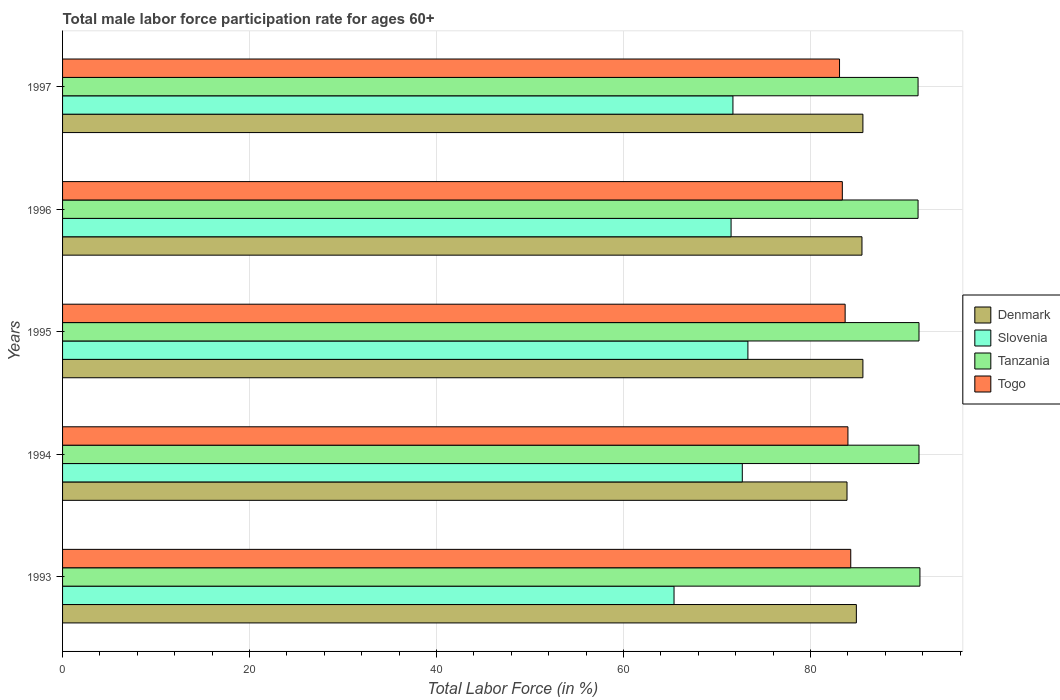How many different coloured bars are there?
Your answer should be very brief. 4. How many groups of bars are there?
Ensure brevity in your answer.  5. Are the number of bars per tick equal to the number of legend labels?
Ensure brevity in your answer.  Yes. Are the number of bars on each tick of the Y-axis equal?
Keep it short and to the point. Yes. How many bars are there on the 2nd tick from the top?
Keep it short and to the point. 4. How many bars are there on the 5th tick from the bottom?
Provide a short and direct response. 4. In how many cases, is the number of bars for a given year not equal to the number of legend labels?
Your answer should be compact. 0. What is the male labor force participation rate in Tanzania in 1995?
Your answer should be very brief. 91.6. Across all years, what is the maximum male labor force participation rate in Togo?
Offer a terse response. 84.3. Across all years, what is the minimum male labor force participation rate in Denmark?
Your answer should be very brief. 83.9. What is the total male labor force participation rate in Slovenia in the graph?
Provide a succinct answer. 354.6. What is the difference between the male labor force participation rate in Slovenia in 1993 and that in 1996?
Provide a short and direct response. -6.1. What is the difference between the male labor force participation rate in Tanzania in 1993 and the male labor force participation rate in Slovenia in 1996?
Make the answer very short. 20.2. What is the average male labor force participation rate in Togo per year?
Ensure brevity in your answer.  83.7. In how many years, is the male labor force participation rate in Denmark greater than 36 %?
Provide a succinct answer. 5. What is the ratio of the male labor force participation rate in Slovenia in 1993 to that in 1996?
Your response must be concise. 0.91. Is the male labor force participation rate in Denmark in 1994 less than that in 1995?
Your response must be concise. Yes. Is the difference between the male labor force participation rate in Denmark in 1994 and 1995 greater than the difference between the male labor force participation rate in Tanzania in 1994 and 1995?
Keep it short and to the point. No. What is the difference between the highest and the second highest male labor force participation rate in Tanzania?
Offer a terse response. 0.1. What is the difference between the highest and the lowest male labor force participation rate in Slovenia?
Make the answer very short. 7.9. In how many years, is the male labor force participation rate in Togo greater than the average male labor force participation rate in Togo taken over all years?
Give a very brief answer. 2. Is the sum of the male labor force participation rate in Denmark in 1995 and 1996 greater than the maximum male labor force participation rate in Slovenia across all years?
Your answer should be compact. Yes. What does the 3rd bar from the top in 1993 represents?
Make the answer very short. Slovenia. What does the 1st bar from the bottom in 1996 represents?
Give a very brief answer. Denmark. How many bars are there?
Ensure brevity in your answer.  20. Are all the bars in the graph horizontal?
Provide a succinct answer. Yes. How many years are there in the graph?
Provide a short and direct response. 5. Does the graph contain any zero values?
Your answer should be compact. No. What is the title of the graph?
Your answer should be very brief. Total male labor force participation rate for ages 60+. What is the label or title of the X-axis?
Provide a succinct answer. Total Labor Force (in %). What is the label or title of the Y-axis?
Your answer should be compact. Years. What is the Total Labor Force (in %) in Denmark in 1993?
Ensure brevity in your answer.  84.9. What is the Total Labor Force (in %) in Slovenia in 1993?
Keep it short and to the point. 65.4. What is the Total Labor Force (in %) in Tanzania in 1993?
Your answer should be very brief. 91.7. What is the Total Labor Force (in %) in Togo in 1993?
Your response must be concise. 84.3. What is the Total Labor Force (in %) of Denmark in 1994?
Your response must be concise. 83.9. What is the Total Labor Force (in %) of Slovenia in 1994?
Provide a succinct answer. 72.7. What is the Total Labor Force (in %) of Tanzania in 1994?
Your response must be concise. 91.6. What is the Total Labor Force (in %) of Denmark in 1995?
Your answer should be compact. 85.6. What is the Total Labor Force (in %) in Slovenia in 1995?
Offer a terse response. 73.3. What is the Total Labor Force (in %) in Tanzania in 1995?
Make the answer very short. 91.6. What is the Total Labor Force (in %) in Togo in 1995?
Make the answer very short. 83.7. What is the Total Labor Force (in %) in Denmark in 1996?
Provide a short and direct response. 85.5. What is the Total Labor Force (in %) in Slovenia in 1996?
Offer a very short reply. 71.5. What is the Total Labor Force (in %) in Tanzania in 1996?
Make the answer very short. 91.5. What is the Total Labor Force (in %) in Togo in 1996?
Offer a very short reply. 83.4. What is the Total Labor Force (in %) of Denmark in 1997?
Give a very brief answer. 85.6. What is the Total Labor Force (in %) in Slovenia in 1997?
Provide a succinct answer. 71.7. What is the Total Labor Force (in %) in Tanzania in 1997?
Your answer should be compact. 91.5. What is the Total Labor Force (in %) in Togo in 1997?
Offer a very short reply. 83.1. Across all years, what is the maximum Total Labor Force (in %) in Denmark?
Make the answer very short. 85.6. Across all years, what is the maximum Total Labor Force (in %) in Slovenia?
Keep it short and to the point. 73.3. Across all years, what is the maximum Total Labor Force (in %) of Tanzania?
Offer a very short reply. 91.7. Across all years, what is the maximum Total Labor Force (in %) of Togo?
Keep it short and to the point. 84.3. Across all years, what is the minimum Total Labor Force (in %) in Denmark?
Provide a short and direct response. 83.9. Across all years, what is the minimum Total Labor Force (in %) in Slovenia?
Offer a terse response. 65.4. Across all years, what is the minimum Total Labor Force (in %) in Tanzania?
Your answer should be compact. 91.5. Across all years, what is the minimum Total Labor Force (in %) of Togo?
Give a very brief answer. 83.1. What is the total Total Labor Force (in %) of Denmark in the graph?
Provide a succinct answer. 425.5. What is the total Total Labor Force (in %) of Slovenia in the graph?
Your response must be concise. 354.6. What is the total Total Labor Force (in %) of Tanzania in the graph?
Your answer should be compact. 457.9. What is the total Total Labor Force (in %) in Togo in the graph?
Your answer should be very brief. 418.5. What is the difference between the Total Labor Force (in %) in Tanzania in 1993 and that in 1994?
Your response must be concise. 0.1. What is the difference between the Total Labor Force (in %) of Togo in 1993 and that in 1994?
Keep it short and to the point. 0.3. What is the difference between the Total Labor Force (in %) in Denmark in 1993 and that in 1995?
Your answer should be compact. -0.7. What is the difference between the Total Labor Force (in %) of Slovenia in 1993 and that in 1995?
Your answer should be very brief. -7.9. What is the difference between the Total Labor Force (in %) of Togo in 1993 and that in 1995?
Ensure brevity in your answer.  0.6. What is the difference between the Total Labor Force (in %) of Togo in 1993 and that in 1996?
Provide a succinct answer. 0.9. What is the difference between the Total Labor Force (in %) of Denmark in 1993 and that in 1997?
Keep it short and to the point. -0.7. What is the difference between the Total Labor Force (in %) of Slovenia in 1993 and that in 1997?
Make the answer very short. -6.3. What is the difference between the Total Labor Force (in %) in Togo in 1993 and that in 1997?
Offer a very short reply. 1.2. What is the difference between the Total Labor Force (in %) of Tanzania in 1994 and that in 1995?
Your response must be concise. 0. What is the difference between the Total Labor Force (in %) in Togo in 1994 and that in 1995?
Your answer should be compact. 0.3. What is the difference between the Total Labor Force (in %) of Slovenia in 1994 and that in 1996?
Your response must be concise. 1.2. What is the difference between the Total Labor Force (in %) in Togo in 1994 and that in 1996?
Your answer should be very brief. 0.6. What is the difference between the Total Labor Force (in %) of Denmark in 1994 and that in 1997?
Make the answer very short. -1.7. What is the difference between the Total Labor Force (in %) in Slovenia in 1994 and that in 1997?
Give a very brief answer. 1. What is the difference between the Total Labor Force (in %) in Togo in 1994 and that in 1997?
Offer a terse response. 0.9. What is the difference between the Total Labor Force (in %) in Denmark in 1995 and that in 1996?
Keep it short and to the point. 0.1. What is the difference between the Total Labor Force (in %) in Togo in 1995 and that in 1996?
Offer a very short reply. 0.3. What is the difference between the Total Labor Force (in %) in Denmark in 1995 and that in 1997?
Your answer should be compact. 0. What is the difference between the Total Labor Force (in %) in Slovenia in 1995 and that in 1997?
Keep it short and to the point. 1.6. What is the difference between the Total Labor Force (in %) of Togo in 1995 and that in 1997?
Make the answer very short. 0.6. What is the difference between the Total Labor Force (in %) in Denmark in 1996 and that in 1997?
Your answer should be very brief. -0.1. What is the difference between the Total Labor Force (in %) in Denmark in 1993 and the Total Labor Force (in %) in Slovenia in 1994?
Provide a short and direct response. 12.2. What is the difference between the Total Labor Force (in %) in Denmark in 1993 and the Total Labor Force (in %) in Togo in 1994?
Your answer should be very brief. 0.9. What is the difference between the Total Labor Force (in %) of Slovenia in 1993 and the Total Labor Force (in %) of Tanzania in 1994?
Your answer should be very brief. -26.2. What is the difference between the Total Labor Force (in %) of Slovenia in 1993 and the Total Labor Force (in %) of Togo in 1994?
Your answer should be compact. -18.6. What is the difference between the Total Labor Force (in %) of Tanzania in 1993 and the Total Labor Force (in %) of Togo in 1994?
Make the answer very short. 7.7. What is the difference between the Total Labor Force (in %) in Denmark in 1993 and the Total Labor Force (in %) in Togo in 1995?
Offer a very short reply. 1.2. What is the difference between the Total Labor Force (in %) in Slovenia in 1993 and the Total Labor Force (in %) in Tanzania in 1995?
Your answer should be compact. -26.2. What is the difference between the Total Labor Force (in %) of Slovenia in 1993 and the Total Labor Force (in %) of Togo in 1995?
Offer a terse response. -18.3. What is the difference between the Total Labor Force (in %) of Tanzania in 1993 and the Total Labor Force (in %) of Togo in 1995?
Provide a short and direct response. 8. What is the difference between the Total Labor Force (in %) in Denmark in 1993 and the Total Labor Force (in %) in Slovenia in 1996?
Give a very brief answer. 13.4. What is the difference between the Total Labor Force (in %) in Slovenia in 1993 and the Total Labor Force (in %) in Tanzania in 1996?
Provide a short and direct response. -26.1. What is the difference between the Total Labor Force (in %) in Tanzania in 1993 and the Total Labor Force (in %) in Togo in 1996?
Ensure brevity in your answer.  8.3. What is the difference between the Total Labor Force (in %) of Denmark in 1993 and the Total Labor Force (in %) of Slovenia in 1997?
Provide a short and direct response. 13.2. What is the difference between the Total Labor Force (in %) of Denmark in 1993 and the Total Labor Force (in %) of Tanzania in 1997?
Ensure brevity in your answer.  -6.6. What is the difference between the Total Labor Force (in %) in Slovenia in 1993 and the Total Labor Force (in %) in Tanzania in 1997?
Your response must be concise. -26.1. What is the difference between the Total Labor Force (in %) in Slovenia in 1993 and the Total Labor Force (in %) in Togo in 1997?
Your response must be concise. -17.7. What is the difference between the Total Labor Force (in %) in Slovenia in 1994 and the Total Labor Force (in %) in Tanzania in 1995?
Your response must be concise. -18.9. What is the difference between the Total Labor Force (in %) in Slovenia in 1994 and the Total Labor Force (in %) in Togo in 1995?
Keep it short and to the point. -11. What is the difference between the Total Labor Force (in %) in Tanzania in 1994 and the Total Labor Force (in %) in Togo in 1995?
Ensure brevity in your answer.  7.9. What is the difference between the Total Labor Force (in %) in Denmark in 1994 and the Total Labor Force (in %) in Slovenia in 1996?
Provide a succinct answer. 12.4. What is the difference between the Total Labor Force (in %) in Denmark in 1994 and the Total Labor Force (in %) in Tanzania in 1996?
Give a very brief answer. -7.6. What is the difference between the Total Labor Force (in %) in Slovenia in 1994 and the Total Labor Force (in %) in Tanzania in 1996?
Keep it short and to the point. -18.8. What is the difference between the Total Labor Force (in %) in Slovenia in 1994 and the Total Labor Force (in %) in Togo in 1996?
Provide a short and direct response. -10.7. What is the difference between the Total Labor Force (in %) in Denmark in 1994 and the Total Labor Force (in %) in Slovenia in 1997?
Your answer should be compact. 12.2. What is the difference between the Total Labor Force (in %) in Denmark in 1994 and the Total Labor Force (in %) in Tanzania in 1997?
Provide a succinct answer. -7.6. What is the difference between the Total Labor Force (in %) in Slovenia in 1994 and the Total Labor Force (in %) in Tanzania in 1997?
Your answer should be very brief. -18.8. What is the difference between the Total Labor Force (in %) in Tanzania in 1994 and the Total Labor Force (in %) in Togo in 1997?
Your answer should be very brief. 8.5. What is the difference between the Total Labor Force (in %) in Denmark in 1995 and the Total Labor Force (in %) in Slovenia in 1996?
Your answer should be compact. 14.1. What is the difference between the Total Labor Force (in %) of Slovenia in 1995 and the Total Labor Force (in %) of Tanzania in 1996?
Offer a very short reply. -18.2. What is the difference between the Total Labor Force (in %) in Tanzania in 1995 and the Total Labor Force (in %) in Togo in 1996?
Make the answer very short. 8.2. What is the difference between the Total Labor Force (in %) of Denmark in 1995 and the Total Labor Force (in %) of Tanzania in 1997?
Your answer should be very brief. -5.9. What is the difference between the Total Labor Force (in %) in Denmark in 1995 and the Total Labor Force (in %) in Togo in 1997?
Offer a terse response. 2.5. What is the difference between the Total Labor Force (in %) of Slovenia in 1995 and the Total Labor Force (in %) of Tanzania in 1997?
Offer a very short reply. -18.2. What is the difference between the Total Labor Force (in %) of Slovenia in 1995 and the Total Labor Force (in %) of Togo in 1997?
Your response must be concise. -9.8. What is the difference between the Total Labor Force (in %) in Tanzania in 1995 and the Total Labor Force (in %) in Togo in 1997?
Offer a very short reply. 8.5. What is the difference between the Total Labor Force (in %) in Denmark in 1996 and the Total Labor Force (in %) in Slovenia in 1997?
Provide a succinct answer. 13.8. What is the difference between the Total Labor Force (in %) of Denmark in 1996 and the Total Labor Force (in %) of Togo in 1997?
Offer a terse response. 2.4. What is the difference between the Total Labor Force (in %) in Slovenia in 1996 and the Total Labor Force (in %) in Togo in 1997?
Offer a very short reply. -11.6. What is the average Total Labor Force (in %) of Denmark per year?
Offer a terse response. 85.1. What is the average Total Labor Force (in %) in Slovenia per year?
Offer a very short reply. 70.92. What is the average Total Labor Force (in %) in Tanzania per year?
Keep it short and to the point. 91.58. What is the average Total Labor Force (in %) in Togo per year?
Your answer should be very brief. 83.7. In the year 1993, what is the difference between the Total Labor Force (in %) of Denmark and Total Labor Force (in %) of Slovenia?
Make the answer very short. 19.5. In the year 1993, what is the difference between the Total Labor Force (in %) in Slovenia and Total Labor Force (in %) in Tanzania?
Offer a terse response. -26.3. In the year 1993, what is the difference between the Total Labor Force (in %) in Slovenia and Total Labor Force (in %) in Togo?
Provide a succinct answer. -18.9. In the year 1994, what is the difference between the Total Labor Force (in %) in Denmark and Total Labor Force (in %) in Tanzania?
Ensure brevity in your answer.  -7.7. In the year 1994, what is the difference between the Total Labor Force (in %) in Slovenia and Total Labor Force (in %) in Tanzania?
Your response must be concise. -18.9. In the year 1995, what is the difference between the Total Labor Force (in %) of Denmark and Total Labor Force (in %) of Slovenia?
Ensure brevity in your answer.  12.3. In the year 1995, what is the difference between the Total Labor Force (in %) in Slovenia and Total Labor Force (in %) in Tanzania?
Give a very brief answer. -18.3. In the year 1996, what is the difference between the Total Labor Force (in %) of Denmark and Total Labor Force (in %) of Slovenia?
Your response must be concise. 14. In the year 1996, what is the difference between the Total Labor Force (in %) of Denmark and Total Labor Force (in %) of Togo?
Your answer should be compact. 2.1. In the year 1996, what is the difference between the Total Labor Force (in %) of Slovenia and Total Labor Force (in %) of Tanzania?
Make the answer very short. -20. In the year 1997, what is the difference between the Total Labor Force (in %) of Denmark and Total Labor Force (in %) of Slovenia?
Give a very brief answer. 13.9. In the year 1997, what is the difference between the Total Labor Force (in %) of Denmark and Total Labor Force (in %) of Tanzania?
Offer a very short reply. -5.9. In the year 1997, what is the difference between the Total Labor Force (in %) in Denmark and Total Labor Force (in %) in Togo?
Offer a terse response. 2.5. In the year 1997, what is the difference between the Total Labor Force (in %) in Slovenia and Total Labor Force (in %) in Tanzania?
Offer a terse response. -19.8. In the year 1997, what is the difference between the Total Labor Force (in %) of Slovenia and Total Labor Force (in %) of Togo?
Provide a succinct answer. -11.4. What is the ratio of the Total Labor Force (in %) of Denmark in 1993 to that in 1994?
Provide a short and direct response. 1.01. What is the ratio of the Total Labor Force (in %) of Slovenia in 1993 to that in 1994?
Make the answer very short. 0.9. What is the ratio of the Total Labor Force (in %) of Tanzania in 1993 to that in 1994?
Make the answer very short. 1. What is the ratio of the Total Labor Force (in %) of Slovenia in 1993 to that in 1995?
Offer a terse response. 0.89. What is the ratio of the Total Labor Force (in %) of Tanzania in 1993 to that in 1995?
Make the answer very short. 1. What is the ratio of the Total Labor Force (in %) in Slovenia in 1993 to that in 1996?
Your response must be concise. 0.91. What is the ratio of the Total Labor Force (in %) of Tanzania in 1993 to that in 1996?
Provide a short and direct response. 1. What is the ratio of the Total Labor Force (in %) of Togo in 1993 to that in 1996?
Provide a succinct answer. 1.01. What is the ratio of the Total Labor Force (in %) in Denmark in 1993 to that in 1997?
Ensure brevity in your answer.  0.99. What is the ratio of the Total Labor Force (in %) of Slovenia in 1993 to that in 1997?
Offer a terse response. 0.91. What is the ratio of the Total Labor Force (in %) of Tanzania in 1993 to that in 1997?
Ensure brevity in your answer.  1. What is the ratio of the Total Labor Force (in %) in Togo in 1993 to that in 1997?
Provide a succinct answer. 1.01. What is the ratio of the Total Labor Force (in %) of Denmark in 1994 to that in 1995?
Offer a terse response. 0.98. What is the ratio of the Total Labor Force (in %) in Tanzania in 1994 to that in 1995?
Offer a terse response. 1. What is the ratio of the Total Labor Force (in %) in Togo in 1994 to that in 1995?
Your answer should be very brief. 1. What is the ratio of the Total Labor Force (in %) of Denmark in 1994 to that in 1996?
Offer a very short reply. 0.98. What is the ratio of the Total Labor Force (in %) of Slovenia in 1994 to that in 1996?
Your answer should be compact. 1.02. What is the ratio of the Total Labor Force (in %) of Tanzania in 1994 to that in 1996?
Offer a terse response. 1. What is the ratio of the Total Labor Force (in %) in Denmark in 1994 to that in 1997?
Offer a very short reply. 0.98. What is the ratio of the Total Labor Force (in %) in Slovenia in 1994 to that in 1997?
Provide a succinct answer. 1.01. What is the ratio of the Total Labor Force (in %) in Togo in 1994 to that in 1997?
Provide a succinct answer. 1.01. What is the ratio of the Total Labor Force (in %) of Slovenia in 1995 to that in 1996?
Give a very brief answer. 1.03. What is the ratio of the Total Labor Force (in %) of Tanzania in 1995 to that in 1996?
Ensure brevity in your answer.  1. What is the ratio of the Total Labor Force (in %) of Slovenia in 1995 to that in 1997?
Your response must be concise. 1.02. What is the ratio of the Total Labor Force (in %) in Tanzania in 1995 to that in 1997?
Your answer should be compact. 1. What is the ratio of the Total Labor Force (in %) in Slovenia in 1996 to that in 1997?
Offer a terse response. 1. What is the ratio of the Total Labor Force (in %) in Togo in 1996 to that in 1997?
Provide a succinct answer. 1. What is the difference between the highest and the second highest Total Labor Force (in %) of Tanzania?
Ensure brevity in your answer.  0.1. What is the difference between the highest and the lowest Total Labor Force (in %) in Denmark?
Offer a very short reply. 1.7. What is the difference between the highest and the lowest Total Labor Force (in %) of Slovenia?
Offer a terse response. 7.9. What is the difference between the highest and the lowest Total Labor Force (in %) in Tanzania?
Provide a short and direct response. 0.2. What is the difference between the highest and the lowest Total Labor Force (in %) in Togo?
Provide a short and direct response. 1.2. 